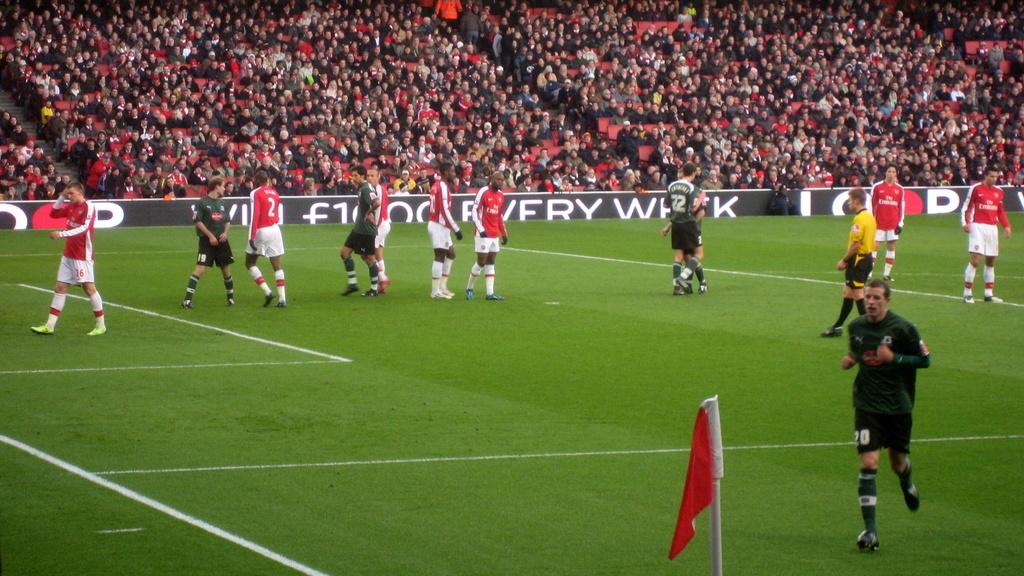<image>
Summarize the visual content of the image. a bunch of soccer players on a field with a sign that says fry on it 